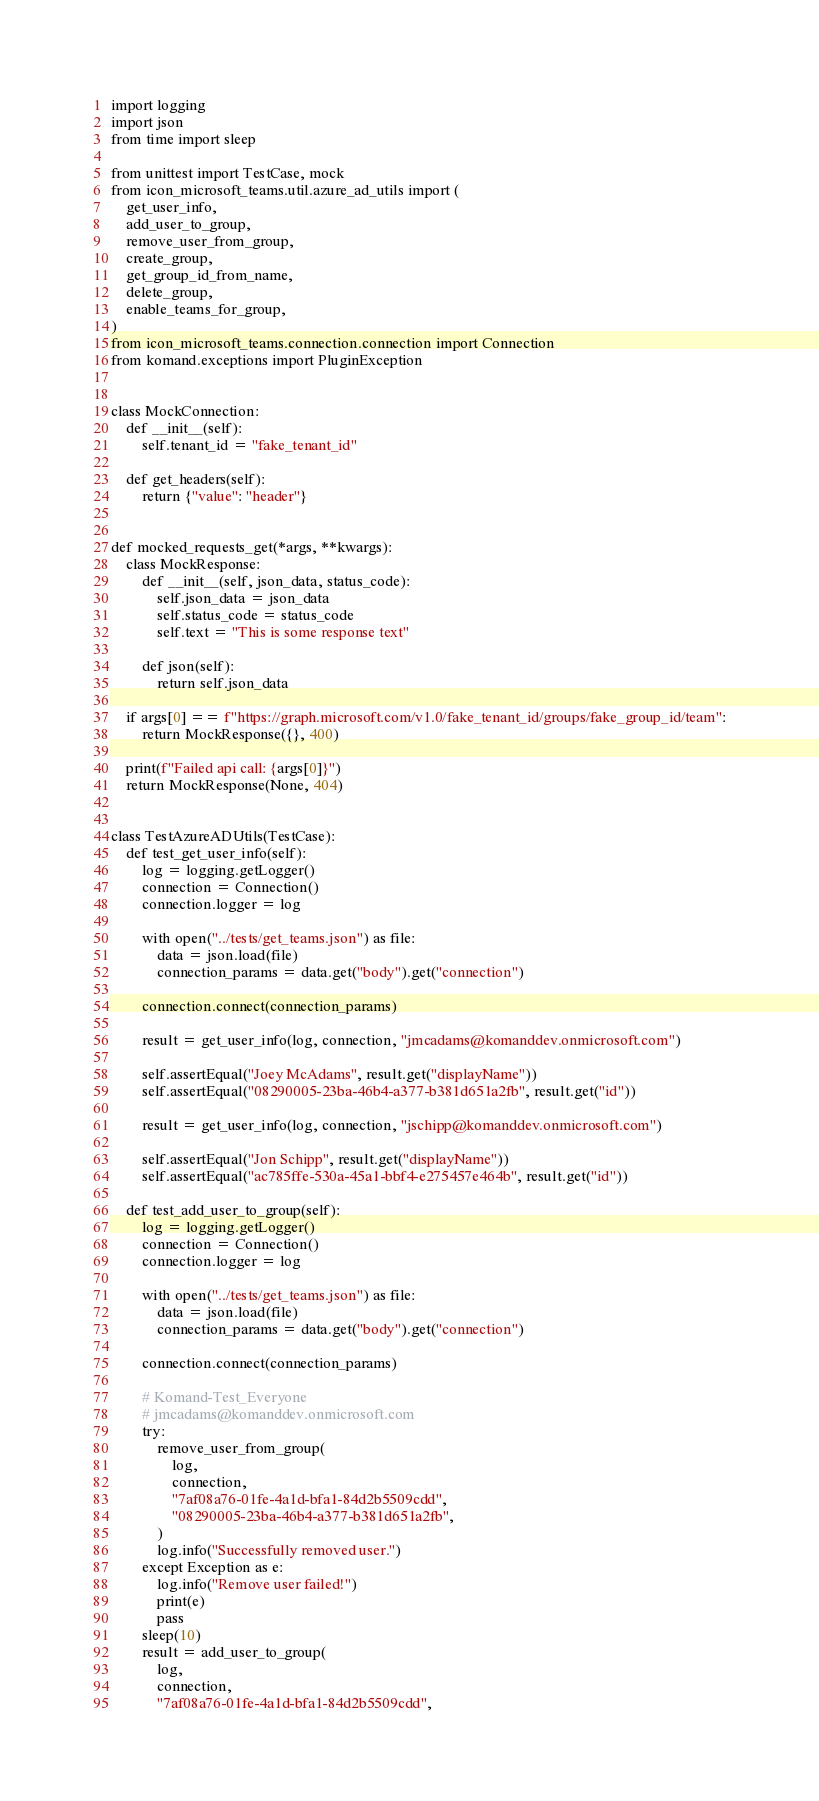<code> <loc_0><loc_0><loc_500><loc_500><_Python_>import logging
import json
from time import sleep

from unittest import TestCase, mock
from icon_microsoft_teams.util.azure_ad_utils import (
    get_user_info,
    add_user_to_group,
    remove_user_from_group,
    create_group,
    get_group_id_from_name,
    delete_group,
    enable_teams_for_group,
)
from icon_microsoft_teams.connection.connection import Connection
from komand.exceptions import PluginException


class MockConnection:
    def __init__(self):
        self.tenant_id = "fake_tenant_id"

    def get_headers(self):
        return {"value": "header"}


def mocked_requests_get(*args, **kwargs):
    class MockResponse:
        def __init__(self, json_data, status_code):
            self.json_data = json_data
            self.status_code = status_code
            self.text = "This is some response text"

        def json(self):
            return self.json_data

    if args[0] == f"https://graph.microsoft.com/v1.0/fake_tenant_id/groups/fake_group_id/team":
        return MockResponse({}, 400)

    print(f"Failed api call: {args[0]}")
    return MockResponse(None, 404)


class TestAzureADUtils(TestCase):
    def test_get_user_info(self):
        log = logging.getLogger()
        connection = Connection()
        connection.logger = log

        with open("../tests/get_teams.json") as file:
            data = json.load(file)
            connection_params = data.get("body").get("connection")

        connection.connect(connection_params)

        result = get_user_info(log, connection, "jmcadams@komanddev.onmicrosoft.com")

        self.assertEqual("Joey McAdams", result.get("displayName"))
        self.assertEqual("08290005-23ba-46b4-a377-b381d651a2fb", result.get("id"))

        result = get_user_info(log, connection, "jschipp@komanddev.onmicrosoft.com")

        self.assertEqual("Jon Schipp", result.get("displayName"))
        self.assertEqual("ac785ffe-530a-45a1-bbf4-e275457e464b", result.get("id"))

    def test_add_user_to_group(self):
        log = logging.getLogger()
        connection = Connection()
        connection.logger = log

        with open("../tests/get_teams.json") as file:
            data = json.load(file)
            connection_params = data.get("body").get("connection")

        connection.connect(connection_params)

        # Komand-Test_Everyone
        # jmcadams@komanddev.onmicrosoft.com
        try:
            remove_user_from_group(
                log,
                connection,
                "7af08a76-01fe-4a1d-bfa1-84d2b5509cdd",
                "08290005-23ba-46b4-a377-b381d651a2fb",
            )
            log.info("Successfully removed user.")
        except Exception as e:
            log.info("Remove user failed!")
            print(e)
            pass
        sleep(10)
        result = add_user_to_group(
            log,
            connection,
            "7af08a76-01fe-4a1d-bfa1-84d2b5509cdd",</code> 